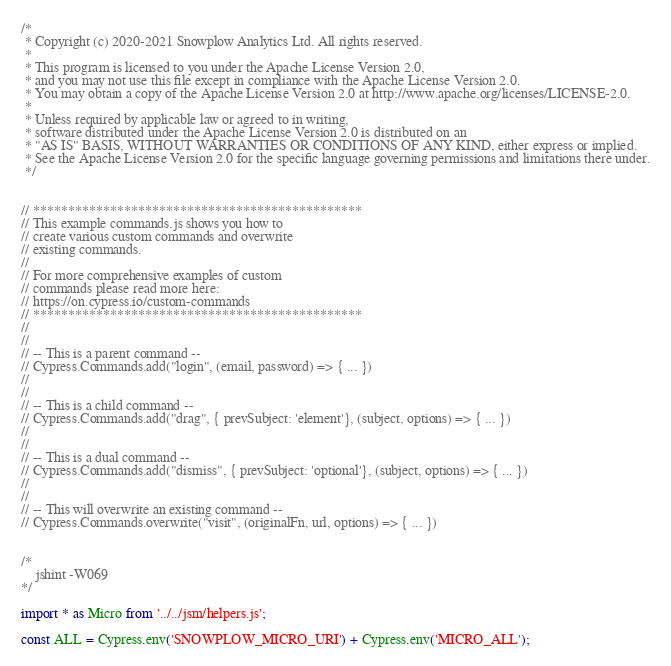Convert code to text. <code><loc_0><loc_0><loc_500><loc_500><_JavaScript_>/*
 * Copyright (c) 2020-2021 Snowplow Analytics Ltd. All rights reserved.
 *
 * This program is licensed to you under the Apache License Version 2.0,
 * and you may not use this file except in compliance with the Apache License Version 2.0.
 * You may obtain a copy of the Apache License Version 2.0 at http://www.apache.org/licenses/LICENSE-2.0.
 *
 * Unless required by applicable law or agreed to in writing,
 * software distributed under the Apache License Version 2.0 is distributed on an
 * "AS IS" BASIS, WITHOUT WARRANTIES OR CONDITIONS OF ANY KIND, either express or implied.
 * See the Apache License Version 2.0 for the specific language governing permissions and limitations there under.
 */


// ***********************************************
// This example commands.js shows you how to
// create various custom commands and overwrite
// existing commands.
//
// For more comprehensive examples of custom
// commands please read more here:
// https://on.cypress.io/custom-commands
// ***********************************************
//
//
// -- This is a parent command --
// Cypress.Commands.add("login", (email, password) => { ... })
//
//
// -- This is a child command --
// Cypress.Commands.add("drag", { prevSubject: 'element'}, (subject, options) => { ... })
//
//
// -- This is a dual command --
// Cypress.Commands.add("dismiss", { prevSubject: 'optional'}, (subject, options) => { ... })
//
//
// -- This will overwrite an existing command --
// Cypress.Commands.overwrite("visit", (originalFn, url, options) => { ... })


/*
    jshint -W069
*/

import * as Micro from '../../jsm/helpers.js';

const ALL = Cypress.env('SNOWPLOW_MICRO_URI') + Cypress.env('MICRO_ALL');</code> 